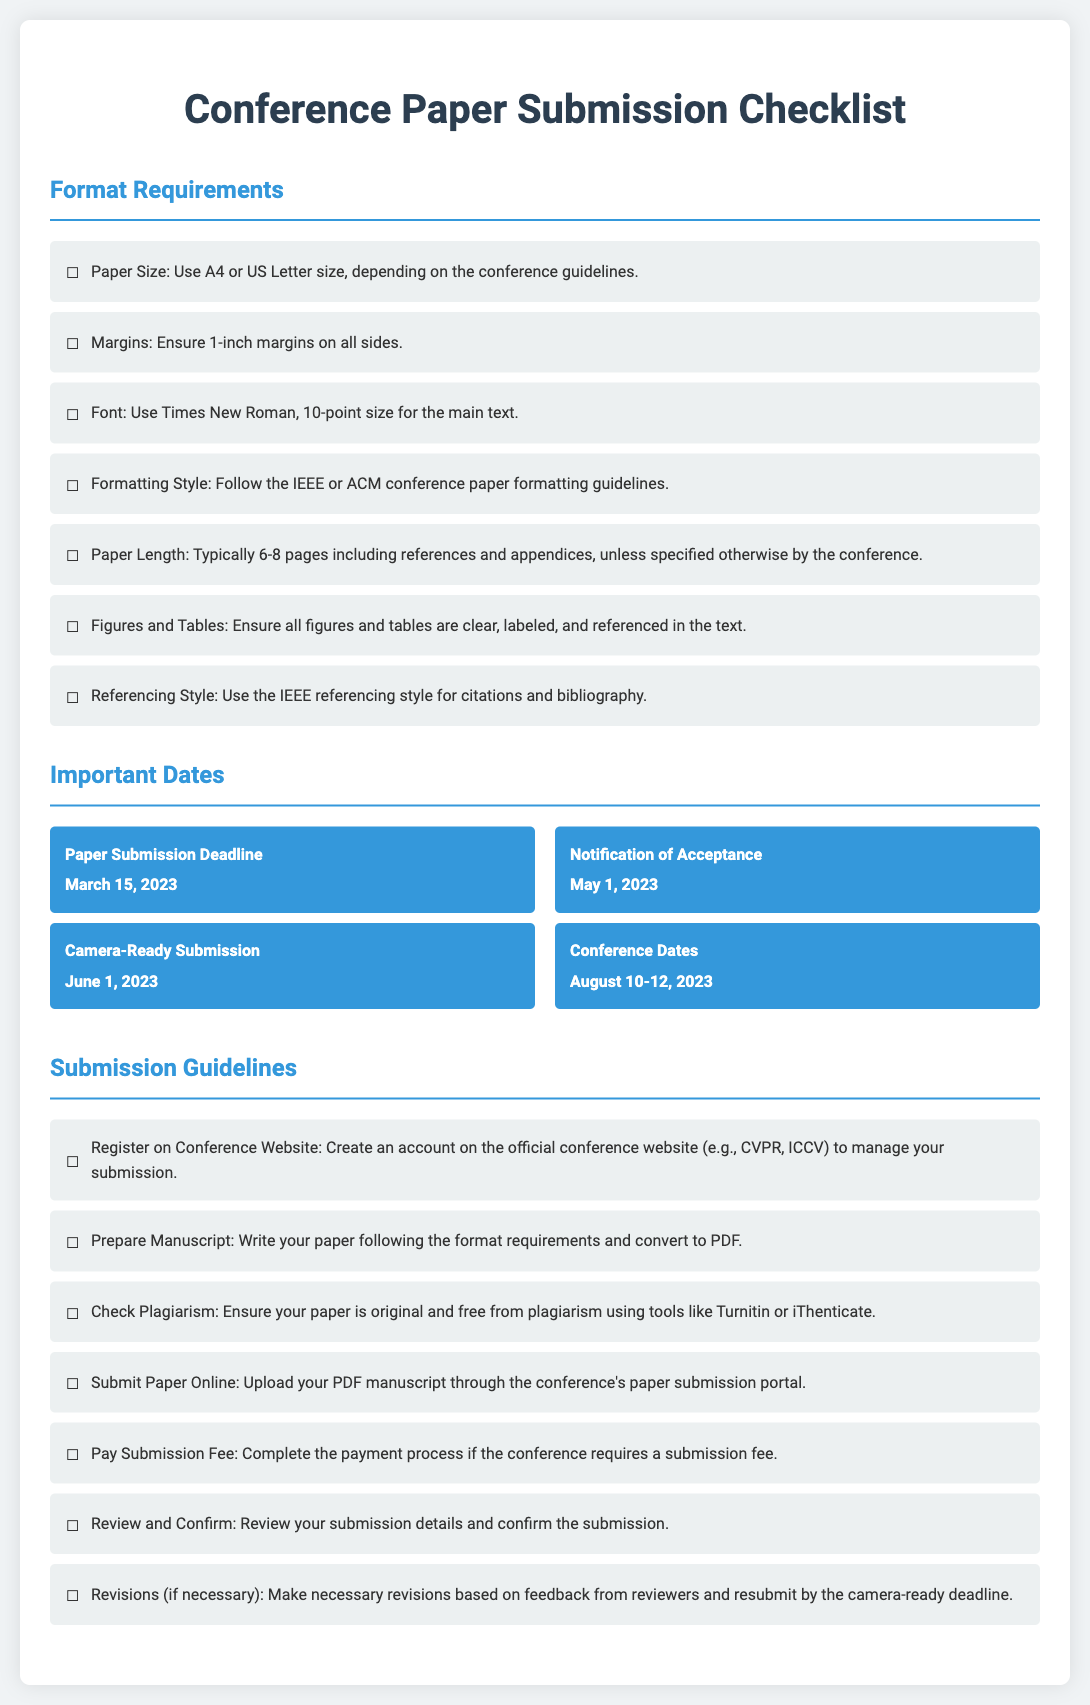what is the paper submission deadline? The paper submission deadline is specified under the Important Dates section of the document.
Answer: March 15, 2023 what font size is required for the main text? The font size is indicated in the Format Requirements section regarding the main text font.
Answer: 10-point size how long should the paper typically be? The expected paper length is mentioned in the Format Requirements section.
Answer: 6-8 pages when is the Notification of Acceptance? The date for Notification of Acceptance is listed in the Important Dates section of the document.
Answer: May 1, 2023 which referencing style should be used for citations? The required referencing style is detailed in the Format Requirements section.
Answer: IEEE referencing style what should you do if revisions are necessary after submission? The process for making revisions is stated in the Submission Guidelines section of the document.
Answer: Make necessary revisions based on feedback from reviewers and resubmit what color is the background of the checklist document? The background color information can be inferred from the style elements in the document.
Answer: Light gray who should you register with to manage your submission? The platform for creating an account is specified in the Submission Guidelines section.
Answer: Conference Website 